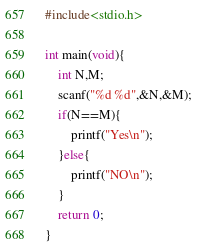Convert code to text. <code><loc_0><loc_0><loc_500><loc_500><_C_>#include<stdio.h>

int main(void){
    int N,M;
    scanf("%d %d",&N,&M);
    if(N==M){
        printf("Yes\n");
    }else{
        printf("NO\n");
    }
    return 0;
}</code> 